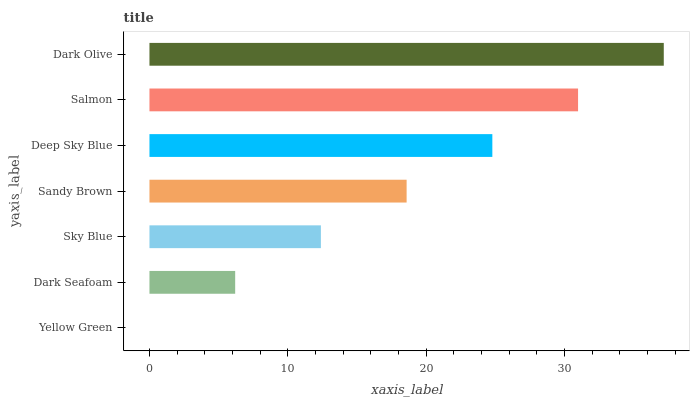Is Yellow Green the minimum?
Answer yes or no. Yes. Is Dark Olive the maximum?
Answer yes or no. Yes. Is Dark Seafoam the minimum?
Answer yes or no. No. Is Dark Seafoam the maximum?
Answer yes or no. No. Is Dark Seafoam greater than Yellow Green?
Answer yes or no. Yes. Is Yellow Green less than Dark Seafoam?
Answer yes or no. Yes. Is Yellow Green greater than Dark Seafoam?
Answer yes or no. No. Is Dark Seafoam less than Yellow Green?
Answer yes or no. No. Is Sandy Brown the high median?
Answer yes or no. Yes. Is Sandy Brown the low median?
Answer yes or no. Yes. Is Yellow Green the high median?
Answer yes or no. No. Is Dark Olive the low median?
Answer yes or no. No. 